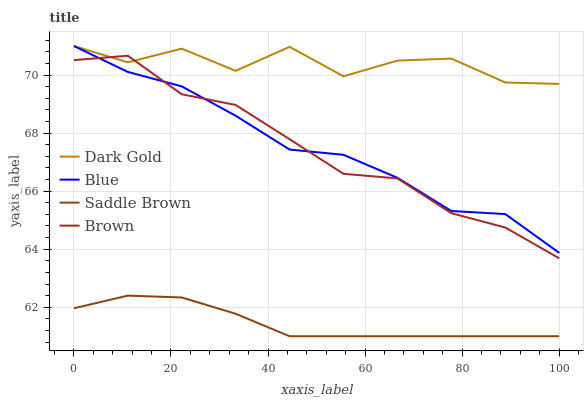Does Saddle Brown have the minimum area under the curve?
Answer yes or no. Yes. Does Dark Gold have the maximum area under the curve?
Answer yes or no. Yes. Does Brown have the minimum area under the curve?
Answer yes or no. No. Does Brown have the maximum area under the curve?
Answer yes or no. No. Is Saddle Brown the smoothest?
Answer yes or no. Yes. Is Dark Gold the roughest?
Answer yes or no. Yes. Is Brown the smoothest?
Answer yes or no. No. Is Brown the roughest?
Answer yes or no. No. Does Saddle Brown have the lowest value?
Answer yes or no. Yes. Does Brown have the lowest value?
Answer yes or no. No. Does Dark Gold have the highest value?
Answer yes or no. Yes. Does Brown have the highest value?
Answer yes or no. No. Is Saddle Brown less than Dark Gold?
Answer yes or no. Yes. Is Dark Gold greater than Saddle Brown?
Answer yes or no. Yes. Does Dark Gold intersect Brown?
Answer yes or no. Yes. Is Dark Gold less than Brown?
Answer yes or no. No. Is Dark Gold greater than Brown?
Answer yes or no. No. Does Saddle Brown intersect Dark Gold?
Answer yes or no. No. 